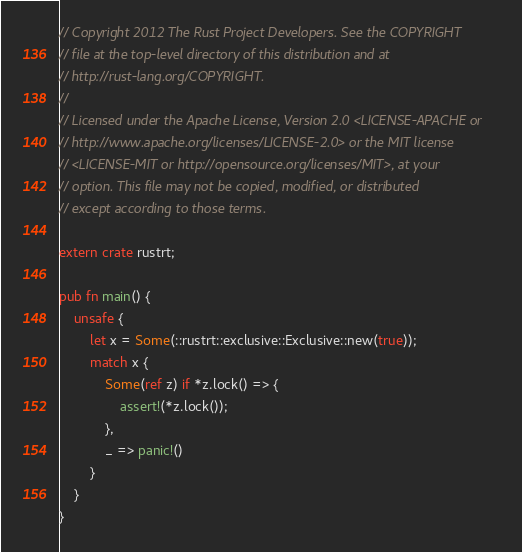<code> <loc_0><loc_0><loc_500><loc_500><_Rust_>// Copyright 2012 The Rust Project Developers. See the COPYRIGHT
// file at the top-level directory of this distribution and at
// http://rust-lang.org/COPYRIGHT.
//
// Licensed under the Apache License, Version 2.0 <LICENSE-APACHE or
// http://www.apache.org/licenses/LICENSE-2.0> or the MIT license
// <LICENSE-MIT or http://opensource.org/licenses/MIT>, at your
// option. This file may not be copied, modified, or distributed
// except according to those terms.

extern crate rustrt;

pub fn main() {
    unsafe {
        let x = Some(::rustrt::exclusive::Exclusive::new(true));
        match x {
            Some(ref z) if *z.lock() => {
                assert!(*z.lock());
            },
            _ => panic!()
        }
    }
}
</code> 